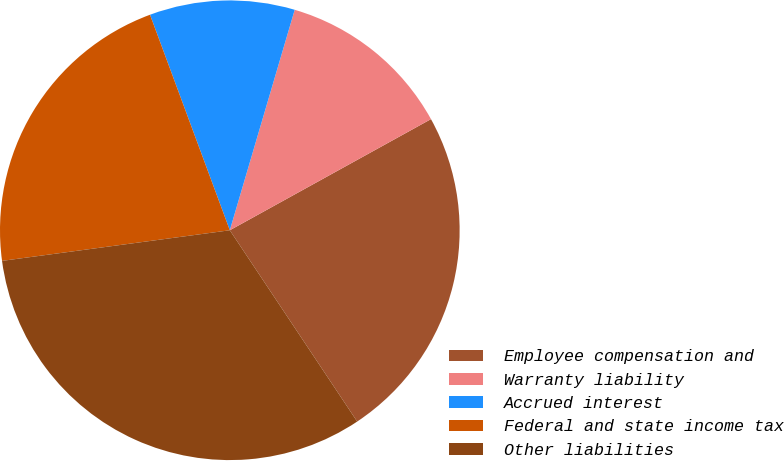Convert chart to OTSL. <chart><loc_0><loc_0><loc_500><loc_500><pie_chart><fcel>Employee compensation and<fcel>Warranty liability<fcel>Accrued interest<fcel>Federal and state income tax<fcel>Other liabilities<nl><fcel>23.68%<fcel>12.41%<fcel>10.2%<fcel>21.48%<fcel>32.22%<nl></chart> 